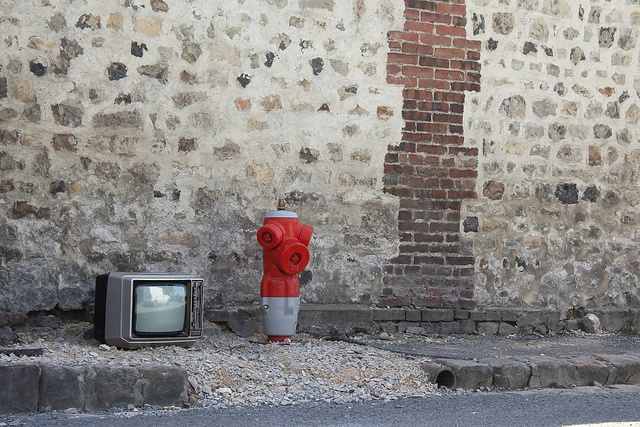Describe the objects in this image and their specific colors. I can see tv in darkgray, gray, and black tones and fire hydrant in darkgray, brown, maroon, and gray tones in this image. 